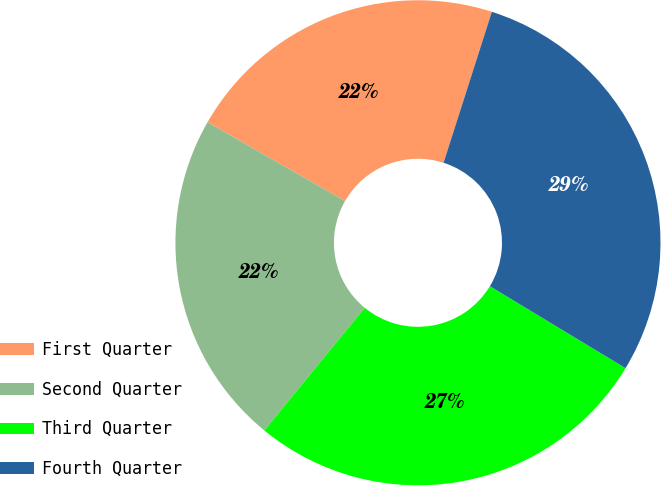<chart> <loc_0><loc_0><loc_500><loc_500><pie_chart><fcel>First Quarter<fcel>Second Quarter<fcel>Third Quarter<fcel>Fourth Quarter<nl><fcel>21.65%<fcel>22.36%<fcel>27.27%<fcel>28.72%<nl></chart> 